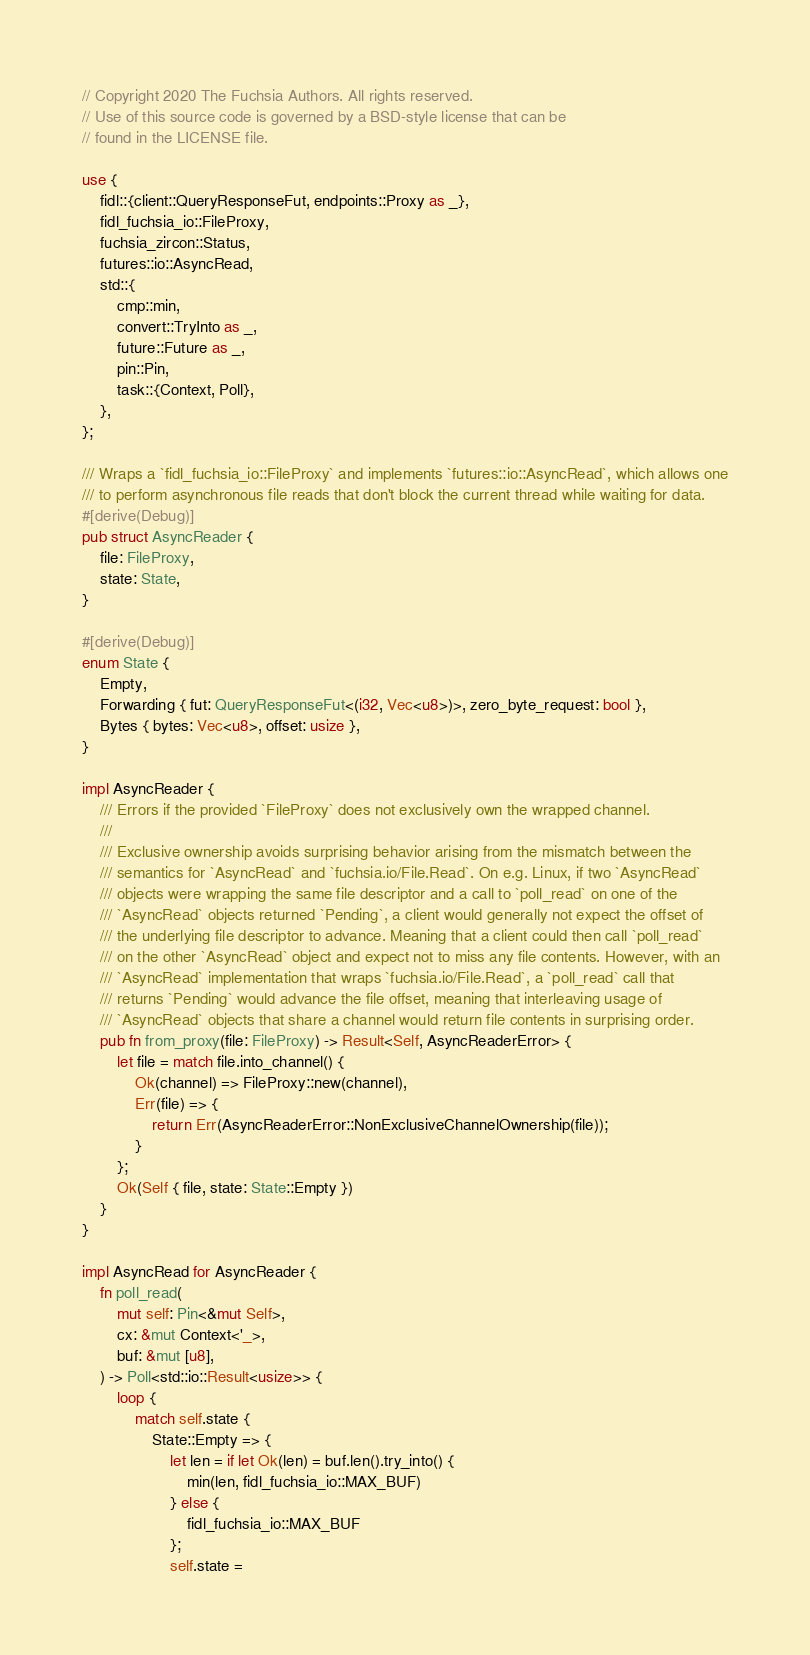<code> <loc_0><loc_0><loc_500><loc_500><_Rust_>// Copyright 2020 The Fuchsia Authors. All rights reserved.
// Use of this source code is governed by a BSD-style license that can be
// found in the LICENSE file.

use {
    fidl::{client::QueryResponseFut, endpoints::Proxy as _},
    fidl_fuchsia_io::FileProxy,
    fuchsia_zircon::Status,
    futures::io::AsyncRead,
    std::{
        cmp::min,
        convert::TryInto as _,
        future::Future as _,
        pin::Pin,
        task::{Context, Poll},
    },
};

/// Wraps a `fidl_fuchsia_io::FileProxy` and implements `futures::io::AsyncRead`, which allows one
/// to perform asynchronous file reads that don't block the current thread while waiting for data.
#[derive(Debug)]
pub struct AsyncReader {
    file: FileProxy,
    state: State,
}

#[derive(Debug)]
enum State {
    Empty,
    Forwarding { fut: QueryResponseFut<(i32, Vec<u8>)>, zero_byte_request: bool },
    Bytes { bytes: Vec<u8>, offset: usize },
}

impl AsyncReader {
    /// Errors if the provided `FileProxy` does not exclusively own the wrapped channel.
    ///
    /// Exclusive ownership avoids surprising behavior arising from the mismatch between the
    /// semantics for `AsyncRead` and `fuchsia.io/File.Read`. On e.g. Linux, if two `AsyncRead`
    /// objects were wrapping the same file descriptor and a call to `poll_read` on one of the
    /// `AsyncRead` objects returned `Pending`, a client would generally not expect the offset of
    /// the underlying file descriptor to advance. Meaning that a client could then call `poll_read`
    /// on the other `AsyncRead` object and expect not to miss any file contents. However, with an
    /// `AsyncRead` implementation that wraps `fuchsia.io/File.Read`, a `poll_read` call that
    /// returns `Pending` would advance the file offset, meaning that interleaving usage of
    /// `AsyncRead` objects that share a channel would return file contents in surprising order.
    pub fn from_proxy(file: FileProxy) -> Result<Self, AsyncReaderError> {
        let file = match file.into_channel() {
            Ok(channel) => FileProxy::new(channel),
            Err(file) => {
                return Err(AsyncReaderError::NonExclusiveChannelOwnership(file));
            }
        };
        Ok(Self { file, state: State::Empty })
    }
}

impl AsyncRead for AsyncReader {
    fn poll_read(
        mut self: Pin<&mut Self>,
        cx: &mut Context<'_>,
        buf: &mut [u8],
    ) -> Poll<std::io::Result<usize>> {
        loop {
            match self.state {
                State::Empty => {
                    let len = if let Ok(len) = buf.len().try_into() {
                        min(len, fidl_fuchsia_io::MAX_BUF)
                    } else {
                        fidl_fuchsia_io::MAX_BUF
                    };
                    self.state =</code> 